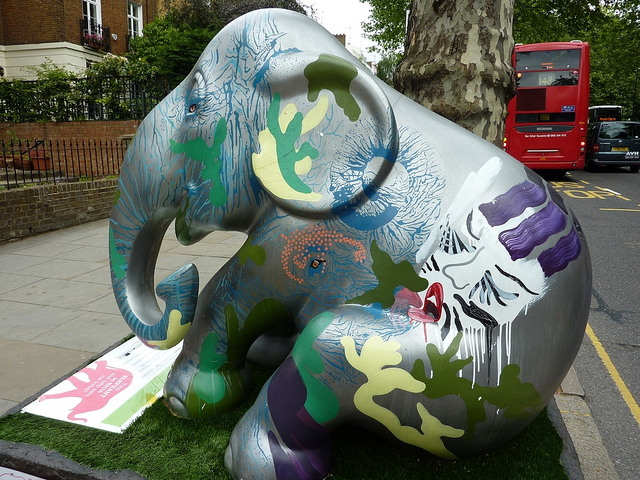Please identify all text content in this image. OP 148 